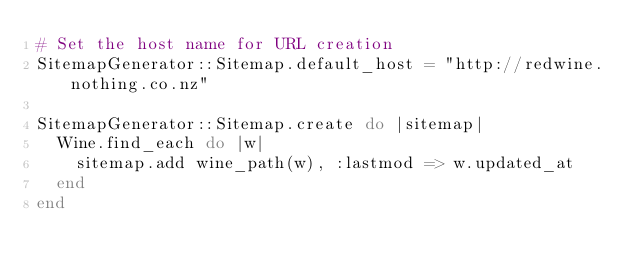Convert code to text. <code><loc_0><loc_0><loc_500><loc_500><_Ruby_># Set the host name for URL creation
SitemapGenerator::Sitemap.default_host = "http://redwine.nothing.co.nz"

SitemapGenerator::Sitemap.create do |sitemap|
  Wine.find_each do |w|
    sitemap.add wine_path(w), :lastmod => w.updated_at
  end
end
</code> 